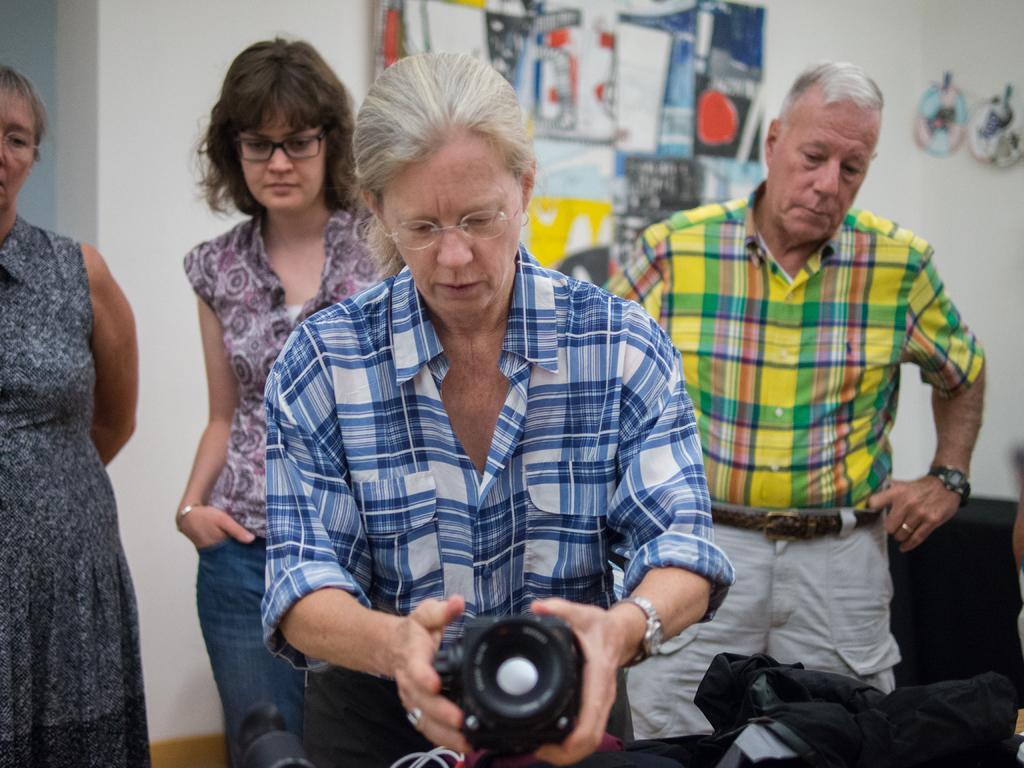How would you summarize this image in a sentence or two? This image is clicked in a room. There are 4 persons in this image. man is standing on the right side, three women at standing. Two around left side and the one who is holding a camera is in the middle. Behind them there are papers pasted on the wall. 